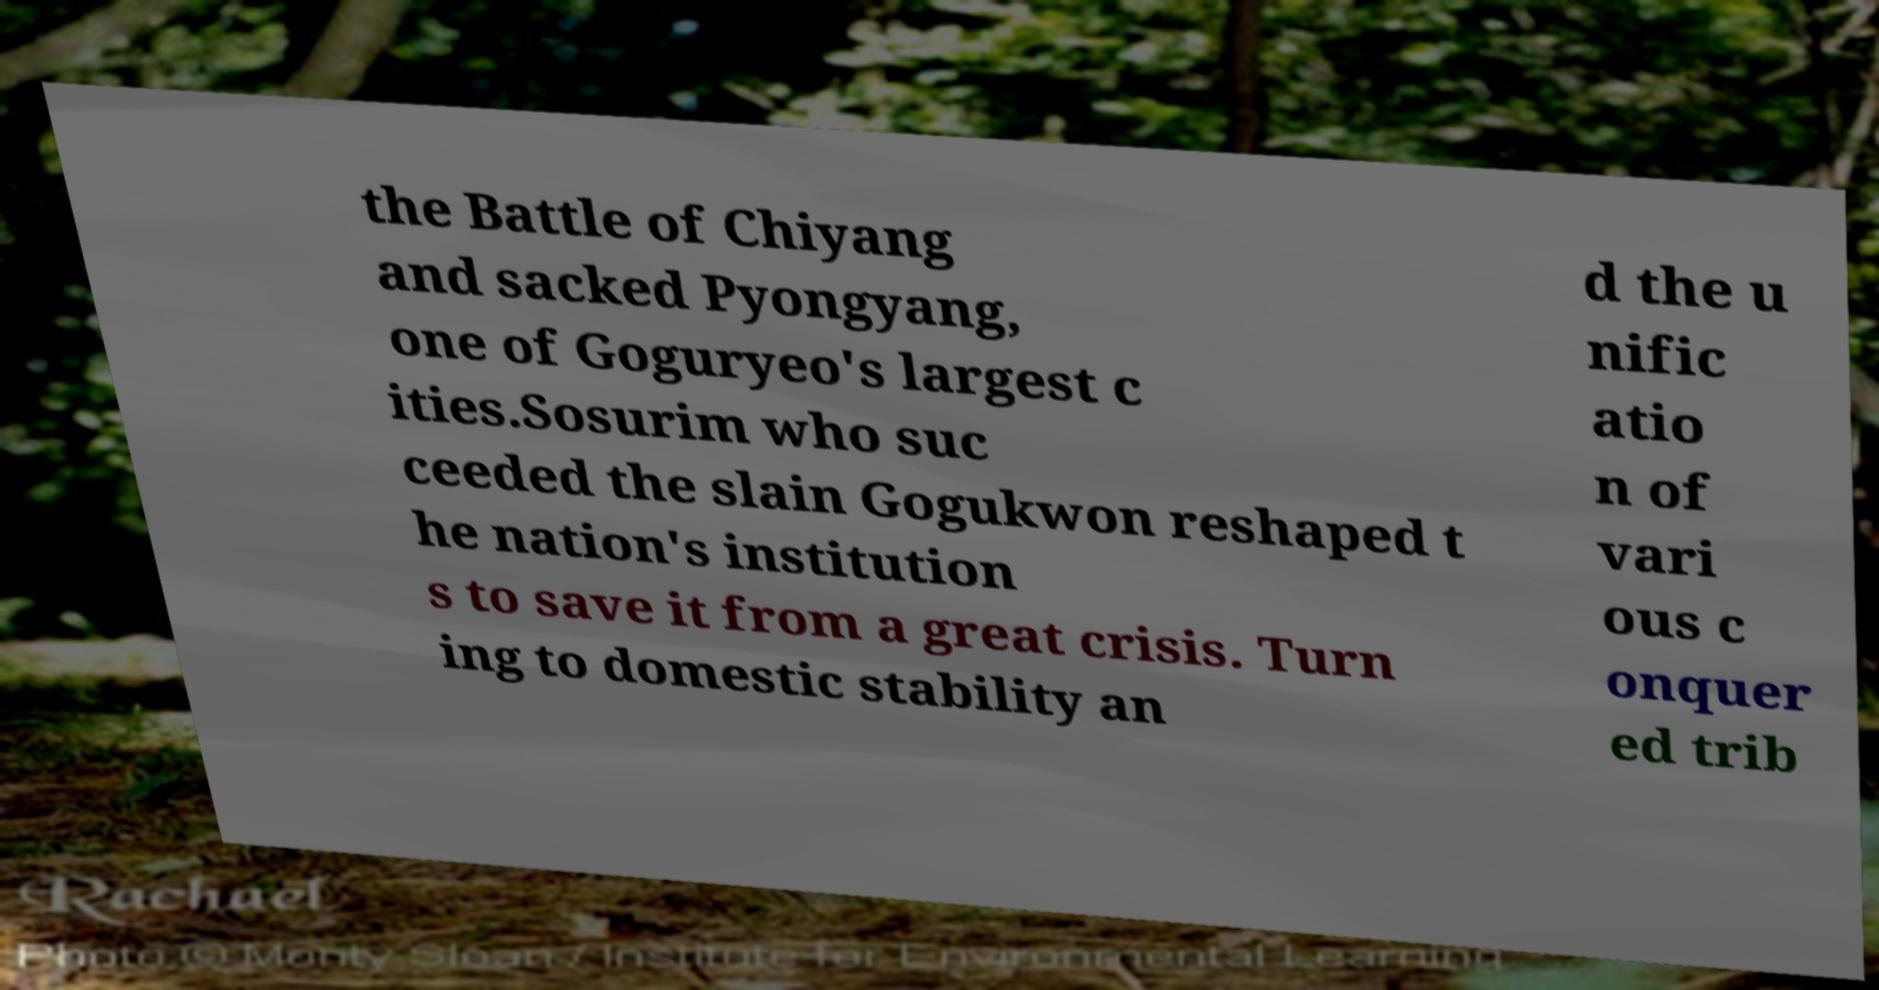Could you assist in decoding the text presented in this image and type it out clearly? the Battle of Chiyang and sacked Pyongyang, one of Goguryeo's largest c ities.Sosurim who suc ceeded the slain Gogukwon reshaped t he nation's institution s to save it from a great crisis. Turn ing to domestic stability an d the u nific atio n of vari ous c onquer ed trib 